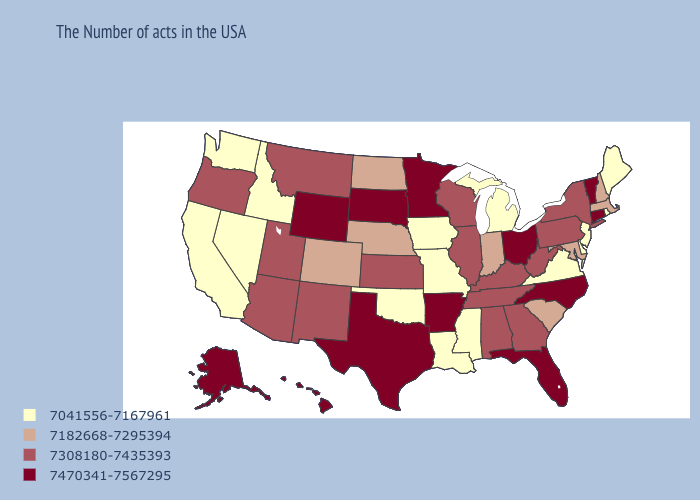Name the states that have a value in the range 7308180-7435393?
Answer briefly. New York, Pennsylvania, West Virginia, Georgia, Kentucky, Alabama, Tennessee, Wisconsin, Illinois, Kansas, New Mexico, Utah, Montana, Arizona, Oregon. Does New Mexico have a higher value than Iowa?
Keep it brief. Yes. Does North Dakota have the same value as New Hampshire?
Answer briefly. Yes. What is the value of South Carolina?
Short answer required. 7182668-7295394. Is the legend a continuous bar?
Answer briefly. No. Does the first symbol in the legend represent the smallest category?
Answer briefly. Yes. Does New Hampshire have a lower value than Alabama?
Keep it brief. Yes. Among the states that border Wisconsin , does Illinois have the lowest value?
Concise answer only. No. What is the value of Arkansas?
Quick response, please. 7470341-7567295. Does Maryland have a lower value than Kentucky?
Quick response, please. Yes. What is the value of Idaho?
Quick response, please. 7041556-7167961. Does Pennsylvania have the lowest value in the Northeast?
Be succinct. No. Name the states that have a value in the range 7182668-7295394?
Answer briefly. Massachusetts, New Hampshire, Maryland, South Carolina, Indiana, Nebraska, North Dakota, Colorado. What is the highest value in the Northeast ?
Give a very brief answer. 7470341-7567295. Is the legend a continuous bar?
Write a very short answer. No. 